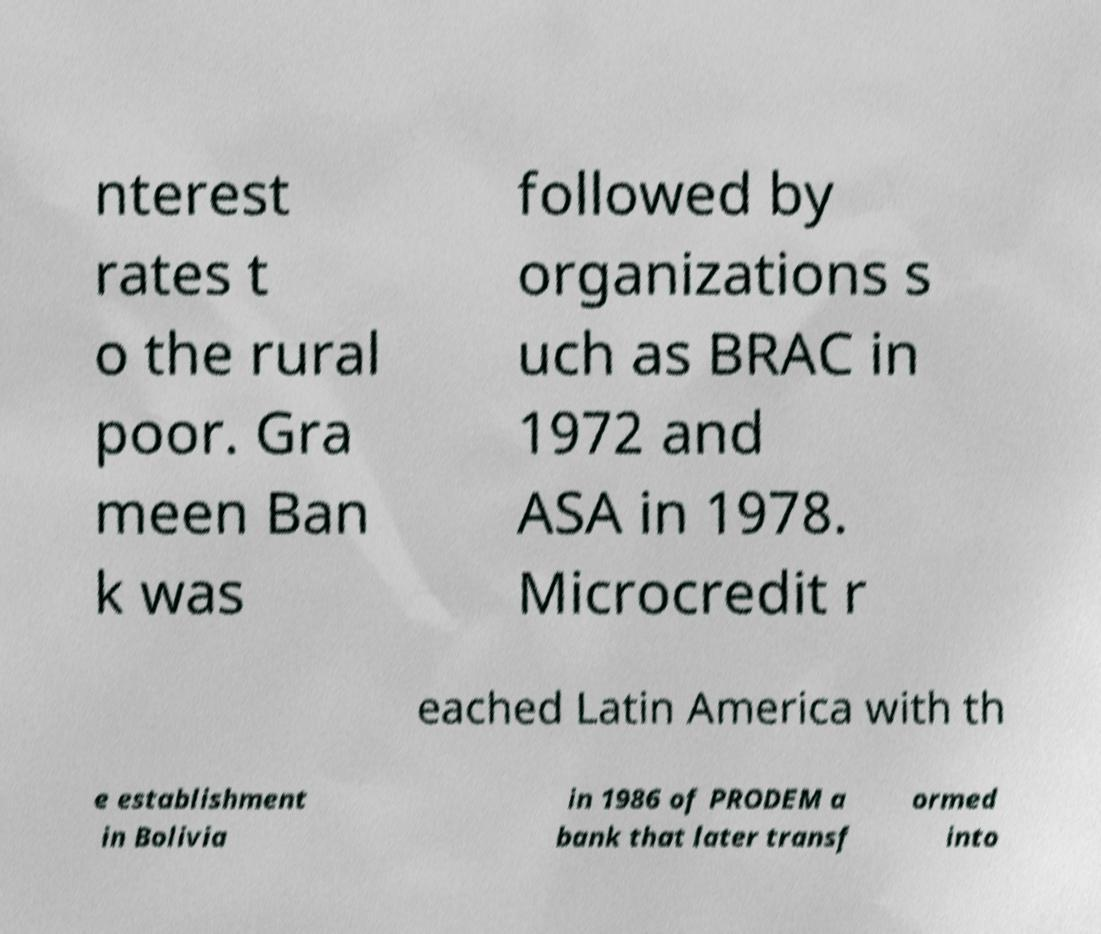There's text embedded in this image that I need extracted. Can you transcribe it verbatim? nterest rates t o the rural poor. Gra meen Ban k was followed by organizations s uch as BRAC in 1972 and ASA in 1978. Microcredit r eached Latin America with th e establishment in Bolivia in 1986 of PRODEM a bank that later transf ormed into 